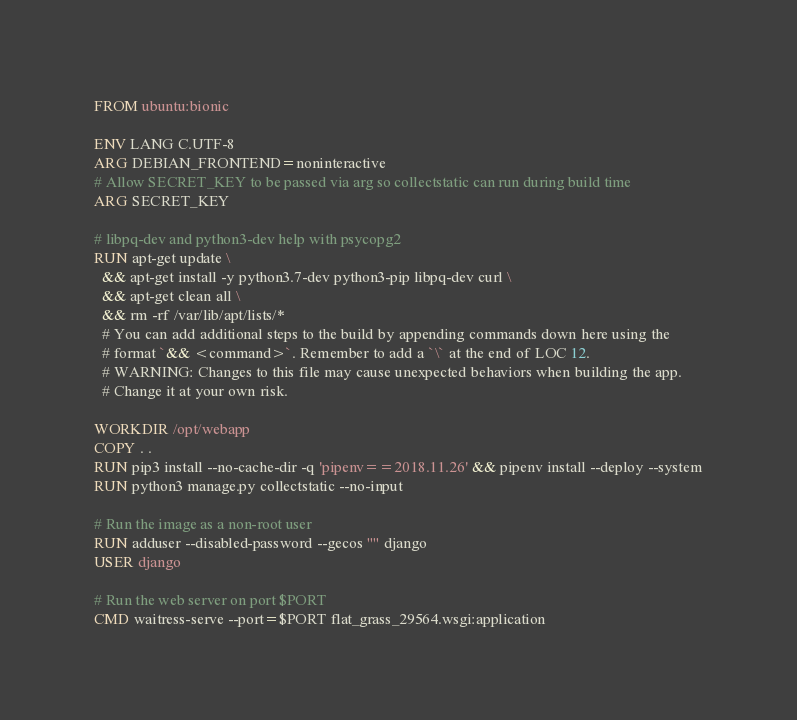<code> <loc_0><loc_0><loc_500><loc_500><_Dockerfile_>FROM ubuntu:bionic

ENV LANG C.UTF-8
ARG DEBIAN_FRONTEND=noninteractive
# Allow SECRET_KEY to be passed via arg so collectstatic can run during build time
ARG SECRET_KEY

# libpq-dev and python3-dev help with psycopg2
RUN apt-get update \
  && apt-get install -y python3.7-dev python3-pip libpq-dev curl \
  && apt-get clean all \
  && rm -rf /var/lib/apt/lists/*
  # You can add additional steps to the build by appending commands down here using the
  # format `&& <command>`. Remember to add a `\` at the end of LOC 12.
  # WARNING: Changes to this file may cause unexpected behaviors when building the app.
  # Change it at your own risk.

WORKDIR /opt/webapp
COPY . .
RUN pip3 install --no-cache-dir -q 'pipenv==2018.11.26' && pipenv install --deploy --system
RUN python3 manage.py collectstatic --no-input

# Run the image as a non-root user
RUN adduser --disabled-password --gecos "" django
USER django

# Run the web server on port $PORT
CMD waitress-serve --port=$PORT flat_grass_29564.wsgi:application
</code> 